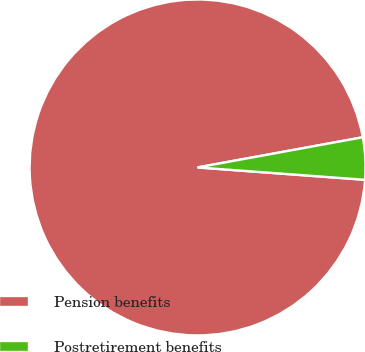Convert chart. <chart><loc_0><loc_0><loc_500><loc_500><pie_chart><fcel>Pension benefits<fcel>Postretirement benefits<nl><fcel>95.95%<fcel>4.05%<nl></chart> 